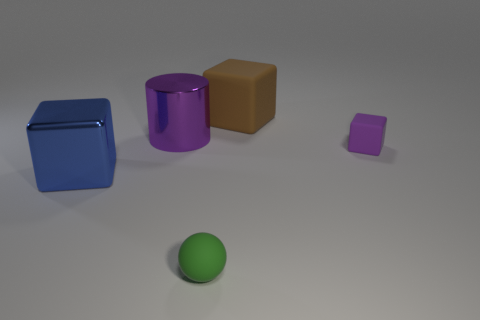Add 3 large purple things. How many objects exist? 8 Subtract all blocks. How many objects are left? 2 Add 5 tiny gray rubber cylinders. How many tiny gray rubber cylinders exist? 5 Subtract 0 cyan cubes. How many objects are left? 5 Subtract all tiny cyan rubber cylinders. Subtract all large cubes. How many objects are left? 3 Add 3 big brown matte objects. How many big brown matte objects are left? 4 